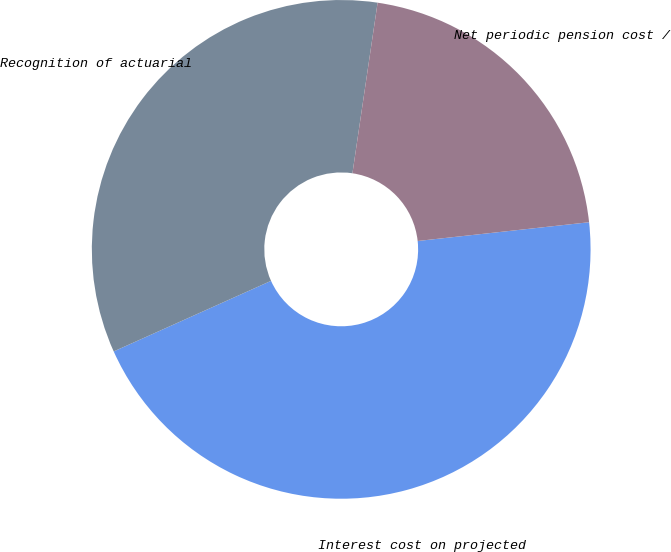Convert chart to OTSL. <chart><loc_0><loc_0><loc_500><loc_500><pie_chart><fcel>Interest cost on projected<fcel>Recognition of actuarial<fcel>Net periodic pension cost /<nl><fcel>45.02%<fcel>34.04%<fcel>20.93%<nl></chart> 